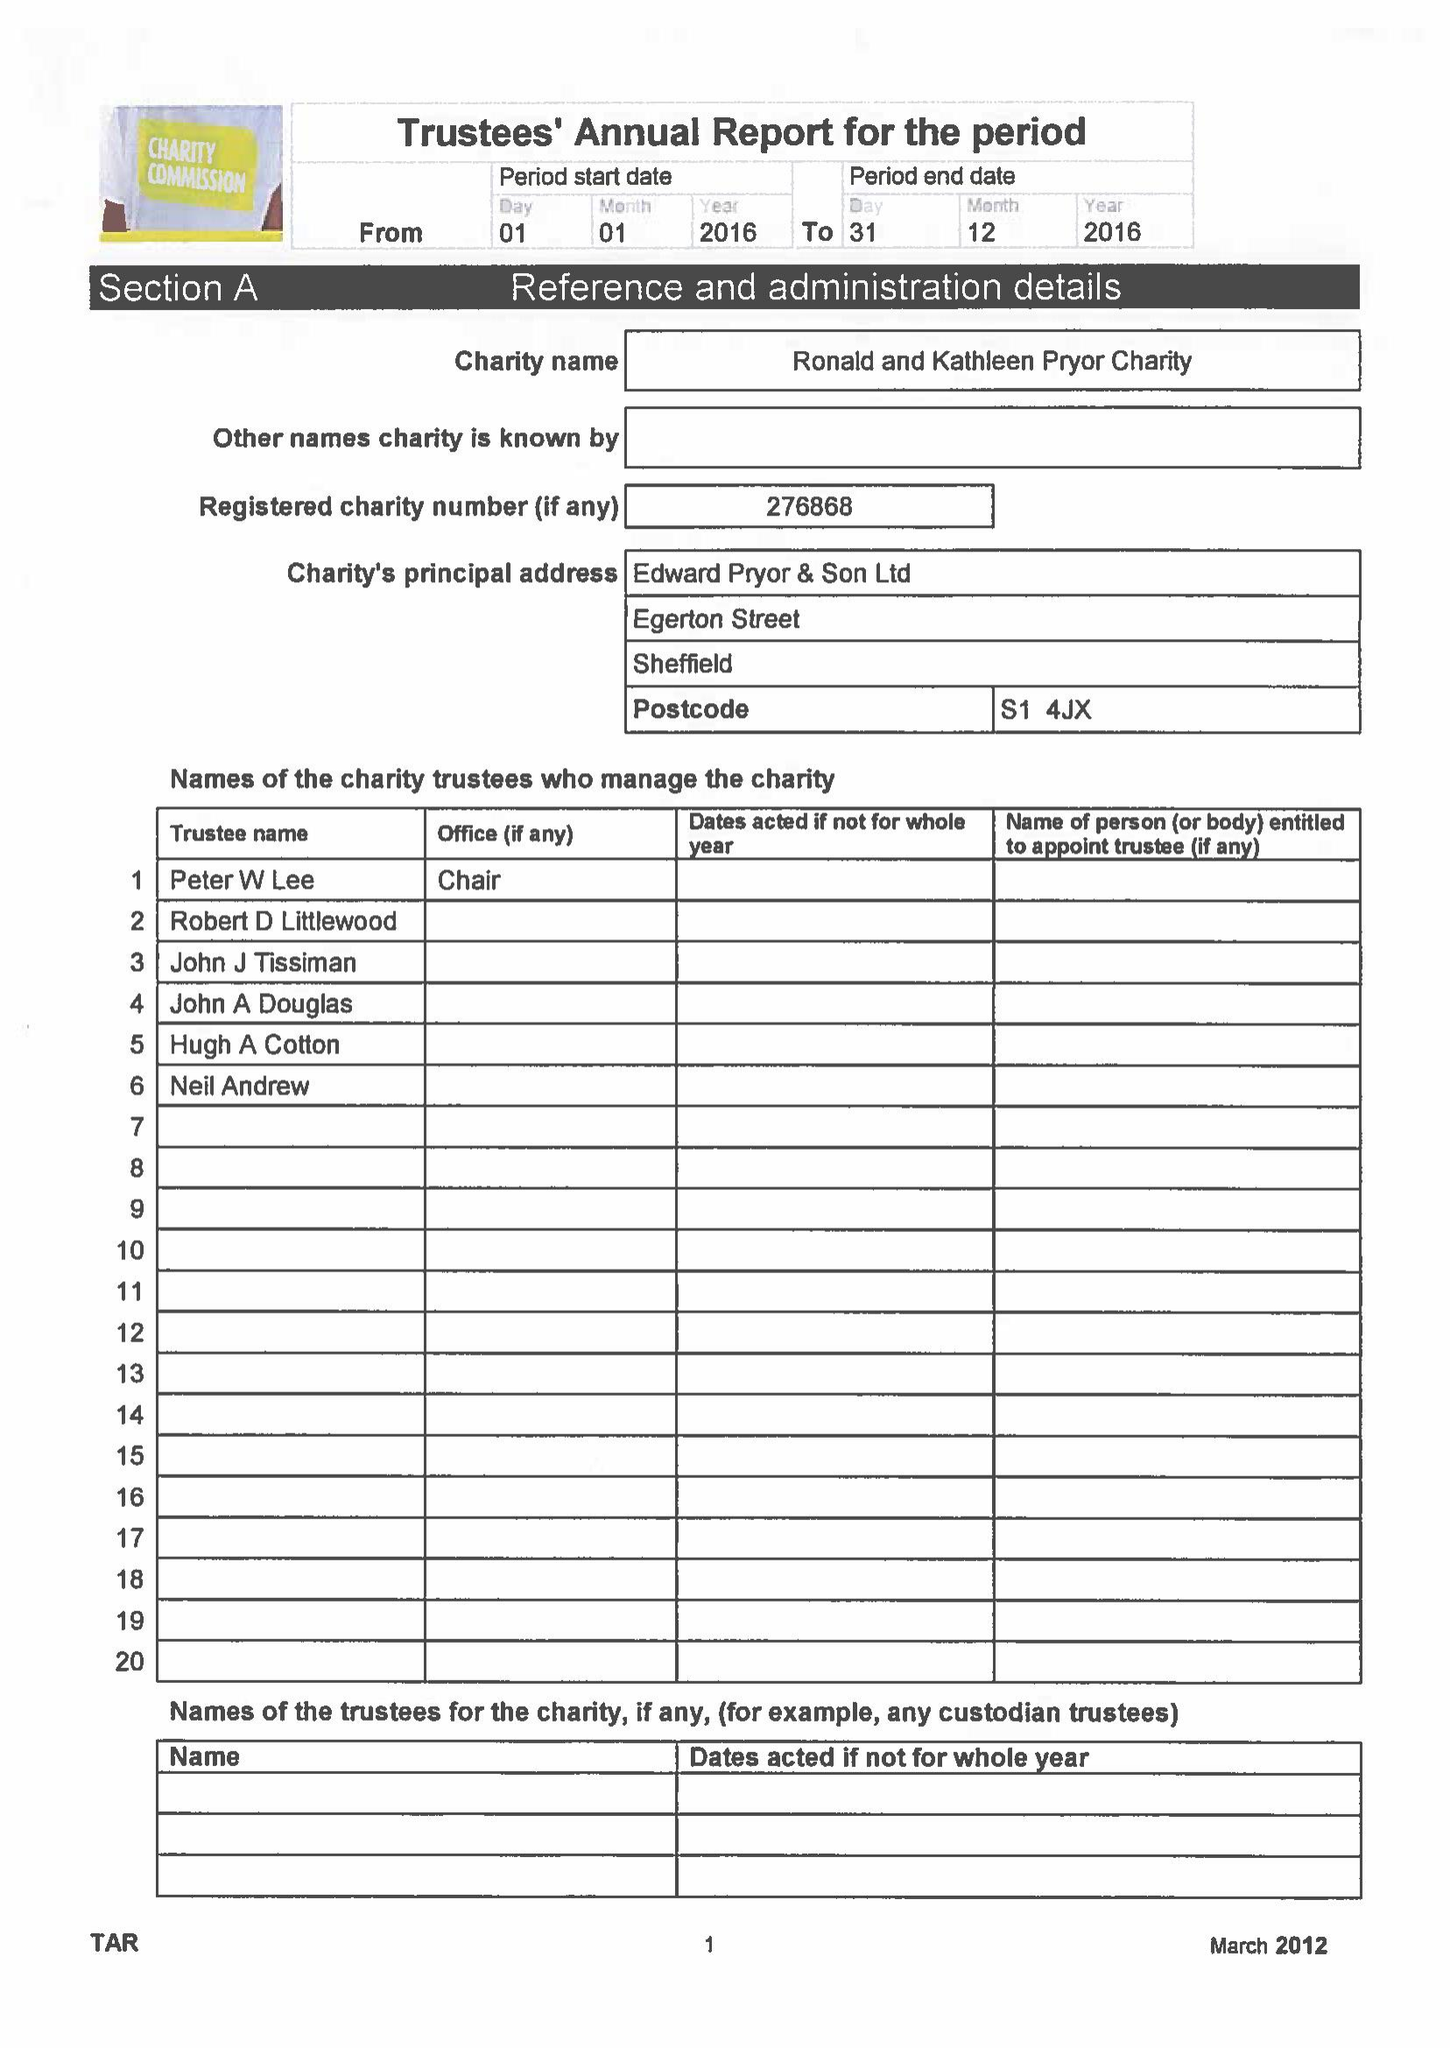What is the value for the spending_annually_in_british_pounds?
Answer the question using a single word or phrase. 19313.00 